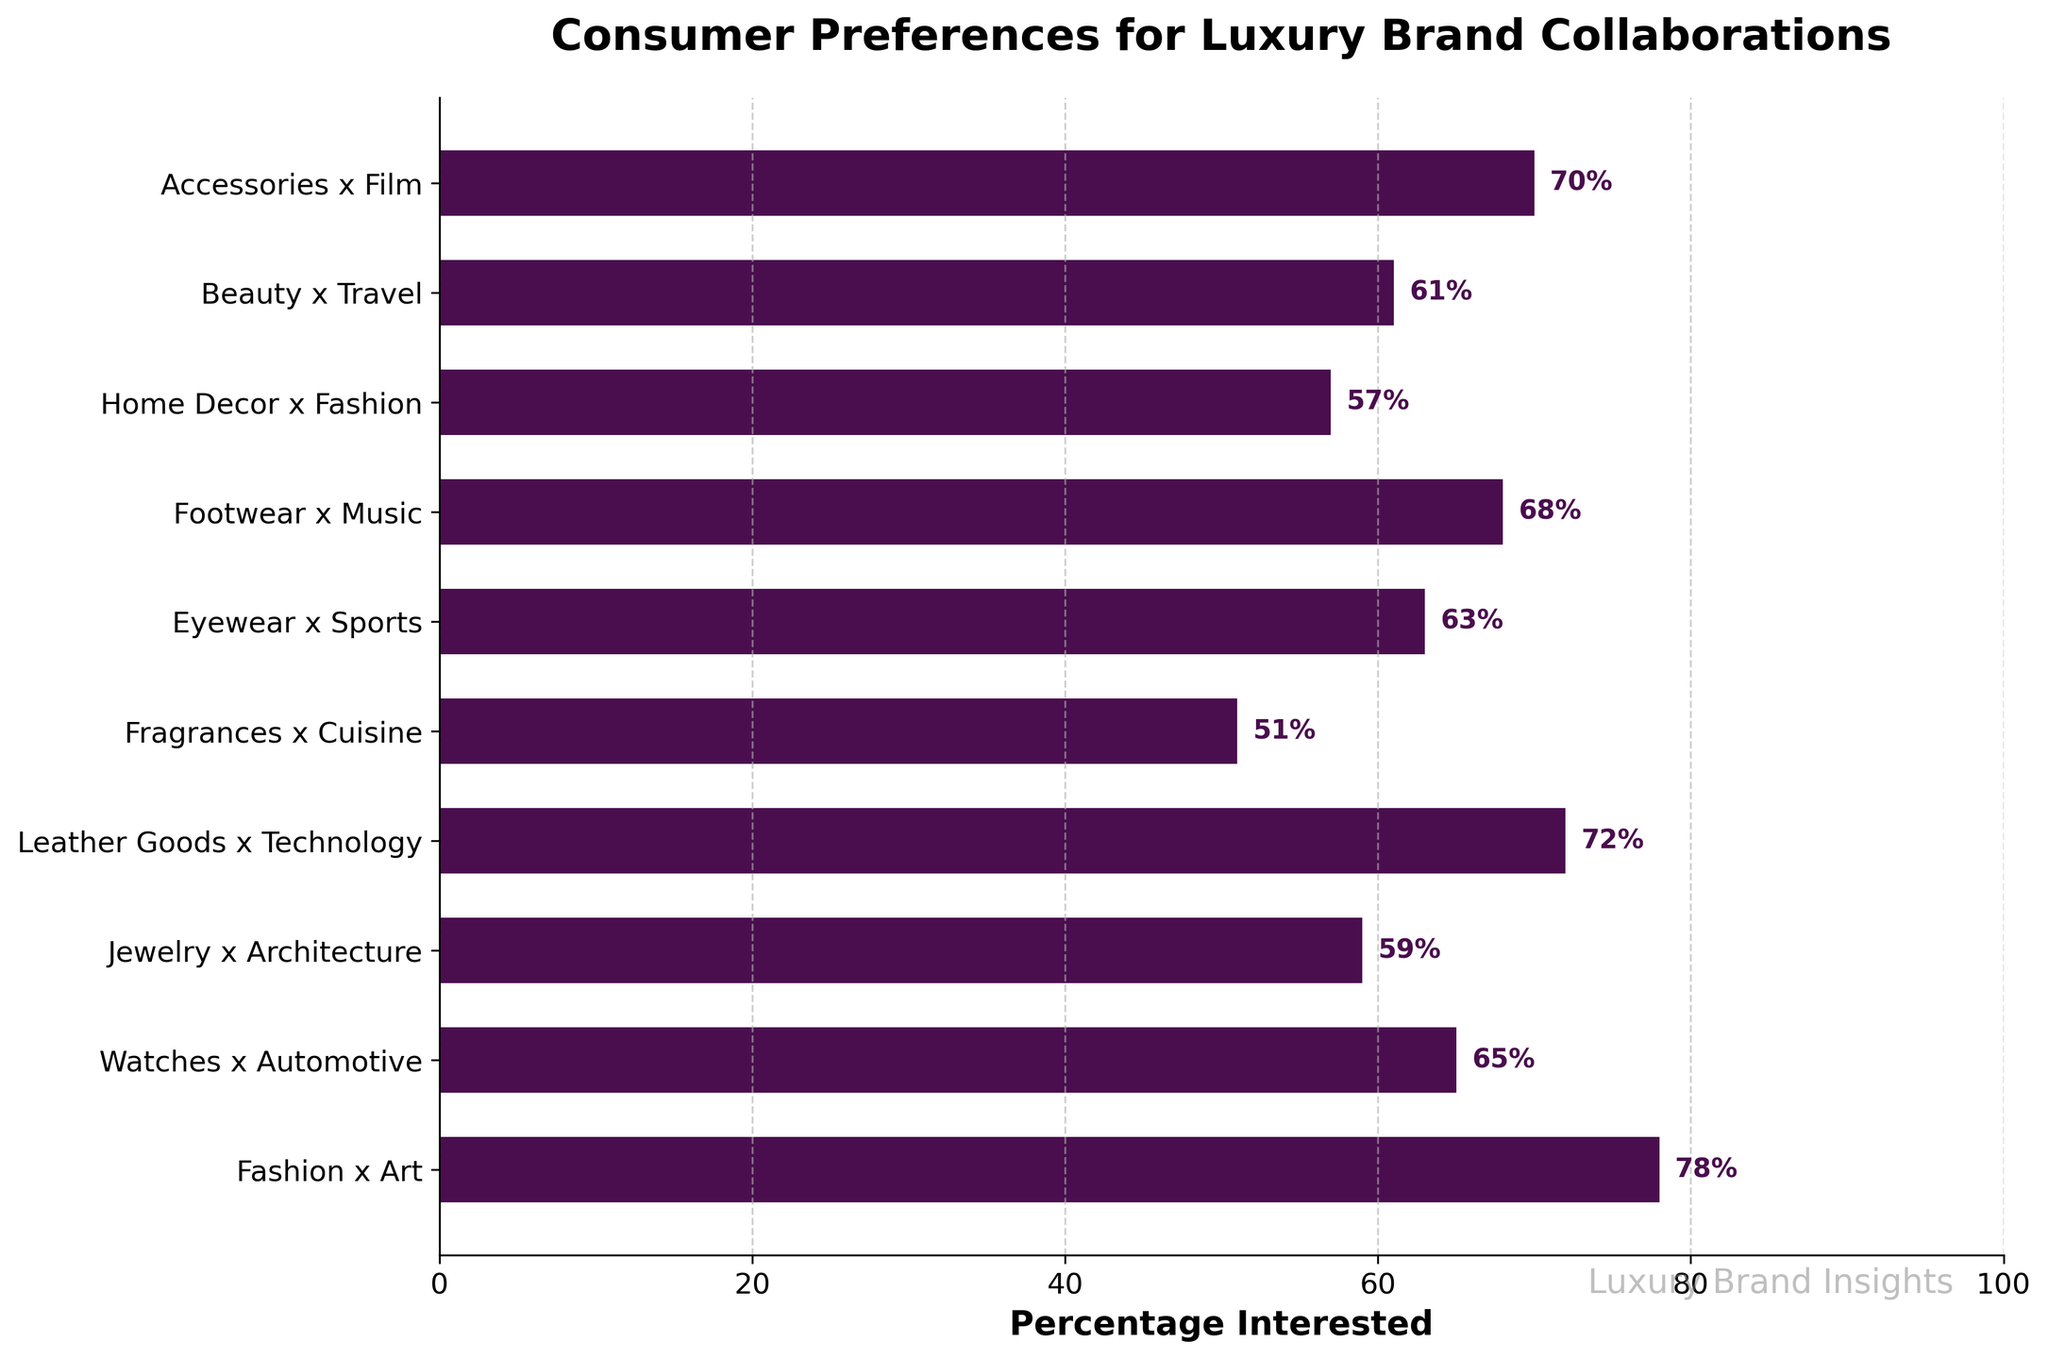Which product line has the highest percentage of consumer interest? The product line with the highest percentage of consumer interest can be identified by finding the longest bar in the chart. The longest bar represents Fashion x Art with 78%.
Answer: Fashion x Art Which product line pairs with `Music` and how does it rank in terms of consumer interest percentage? Locate the bar labeled `Footwear x Music` in the chart. It shows a percentage of 68%. To determine its rank, compare it against other bars. It falls in fourth place.
Answer: Footwear x Music, 4th What's the sum of the percentages for the `Fragrances x Cuisine` and `Beauty x Travel` product lines? Identify the bars for `Fragrances x Cuisine` (51%) and `Beauty x Travel` (61%). Add these percentages: 51% + 61% = 112%.
Answer: 112% Is the consumer interest in `Eyewear x Sports` greater than `Jewelry x Architecture`? Compare the lengths of the bars for `Eyewear x Sports` (63%) and `Jewelry x Architecture` (59%). Since 63% is greater than 59%, the answer is yes.
Answer: Yes What is the average consumer interest percentage for `Watches x Automotive`, `Accessories x Film`, and `Home Decor x Fashion`? The percentages for these product lines are `Watches x Automotive` (65%), `Accessories x Film` (70%), and `Home Decor x Fashion` (57%). Add these percentages and divide by 3: (65% + 70% + 57%) / 3 = 64%.
Answer: 64% Which product lines have interest percentages greater than 70%? Identify the bars with percentages above 70%. These are `Fashion x Art` (78%) and `Leather Goods x Technology` (72%).
Answer: Fashion x Art, Leather Goods x Technology 